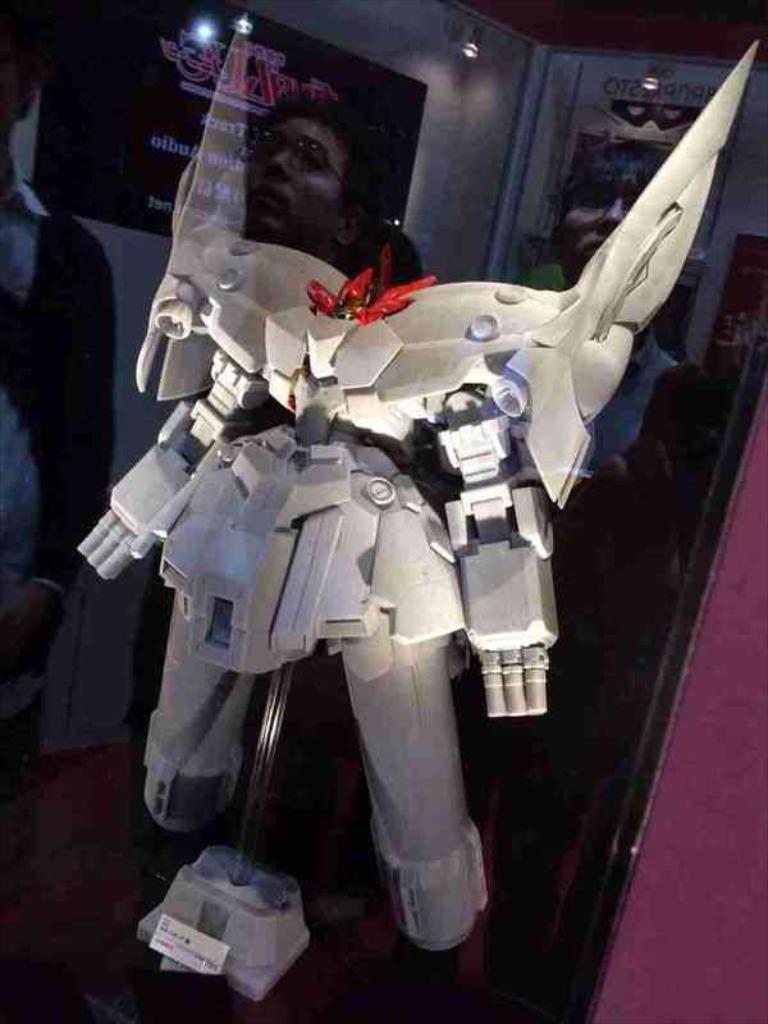Could you give a brief overview of what you see in this image? In this image we can see a robot on a stand. In the back there is a wall with posters. Also there are lights. 